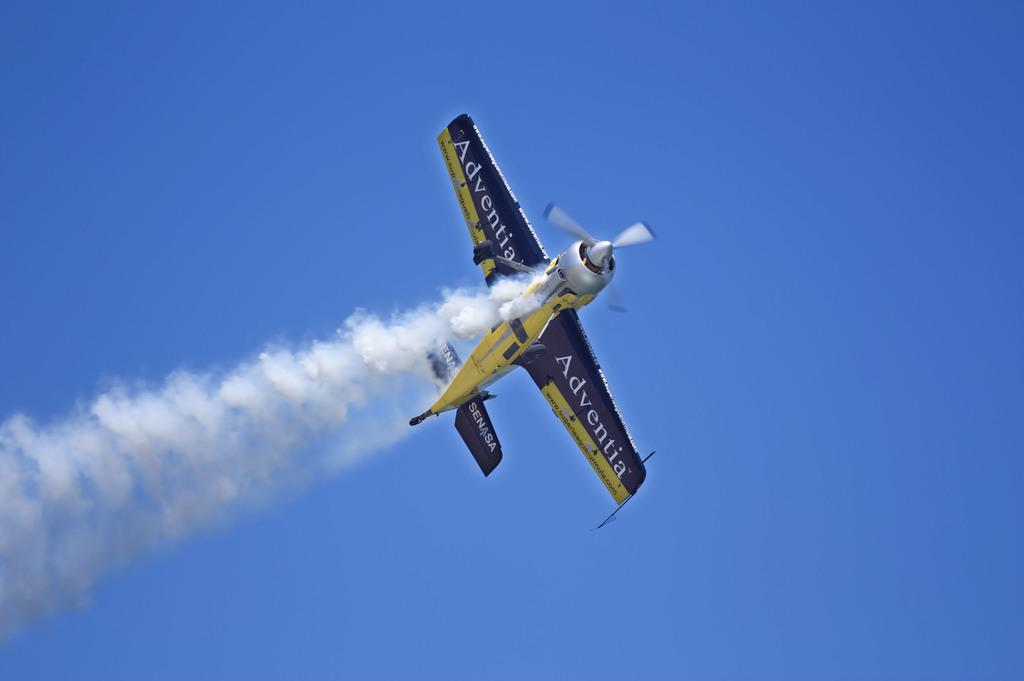What is happening in the sky in the image? There is a flight visible in the sky in the image. What else can be seen in the image besides the flight? There is smoke visible in the image. What is the title of the page that the flight is on in the image? There is no page or title present in the image, as it is a photograph of a flight in the sky. 